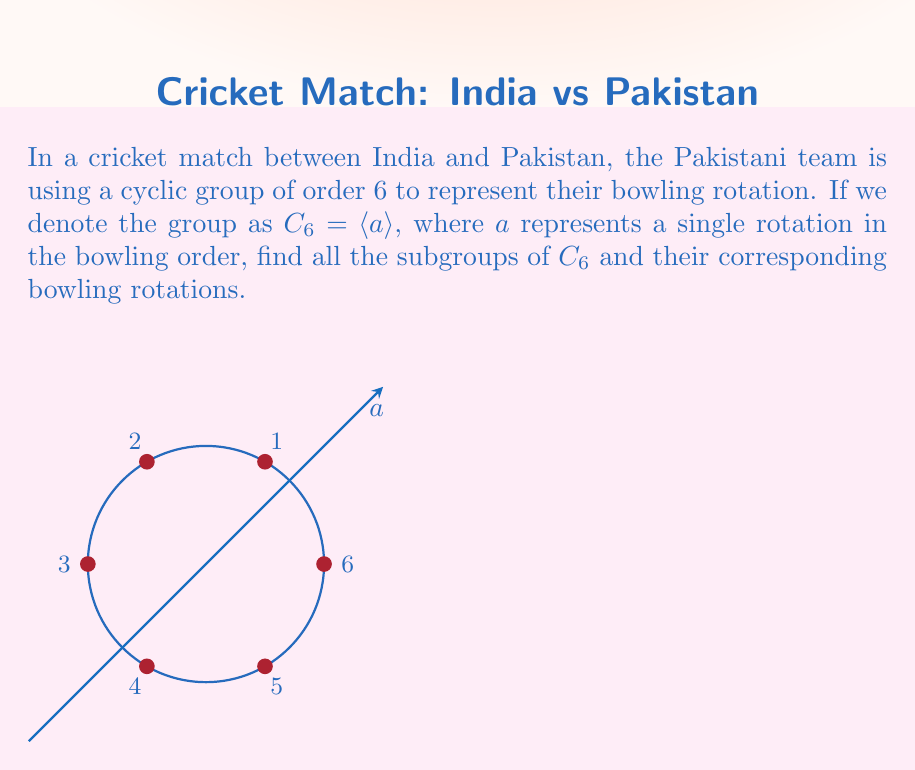Can you answer this question? Let's approach this step-by-step:

1) First, recall that the subgroups of a cyclic group $C_n$ are precisely the cyclic groups $C_d$ where $d$ divides $n$.

2) The divisors of 6 are 1, 2, 3, and 6. So, we expect to find subgroups of orders 1, 2, 3, and 6.

3) Let's find these subgroups:

   a) The trivial subgroup: $\{e\} = \langle a^6 \rangle$
      This represents no change in the bowling order.

   b) Subgroup of order 2: $\{e, a^3\} = \langle a^3 \rangle$
      This represents alternating between two sets of three bowlers.

   c) Subgroup of order 3: $\{e, a^2, a^4\} = \langle a^2 \rangle$
      This represents cycling through two sets of three bowlers.

   d) The whole group: $\{e, a, a^2, a^3, a^4, a^5\} = \langle a \rangle = C_6$
      This represents the full rotation through all six bowlers.

4) We can verify that these are indeed all the subgroups:
   - $\langle a \rangle = C_6$
   - $\langle a^2 \rangle = C_3$
   - $\langle a^3 \rangle = C_2$
   - $\langle a^6 \rangle = C_1 = \{e\}$

5) In terms of bowling rotations:
   - $\langle a \rangle$: Full rotation (1 → 2 → 3 → 4 → 5 → 6 → 1)
   - $\langle a^2 \rangle$: Rotate by two (1 → 3 → 5 → 1 and 2 → 4 → 6 → 2)
   - $\langle a^3 \rangle$: Alternate between two sets (1 → 4 → 1 and 2 → 5 → 2 and 3 → 6 → 3)
   - $\langle a^6 \rangle$: No rotation
Answer: The subgroups of $C_6$ are $\{e\}$, $\langle a^3 \rangle$, $\langle a^2 \rangle$, and $\langle a \rangle$. 